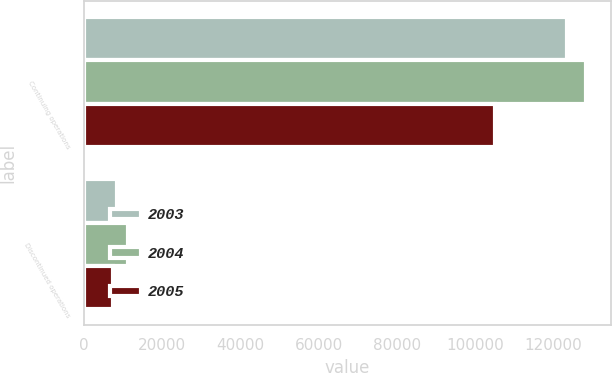Convert chart to OTSL. <chart><loc_0><loc_0><loc_500><loc_500><stacked_bar_chart><ecel><fcel>Continuing operations<fcel>Discontinued operations<nl><fcel>2003<fcel>123675<fcel>8377<nl><fcel>2004<fcel>128332<fcel>11298<nl><fcel>2005<fcel>105173<fcel>7302<nl></chart> 